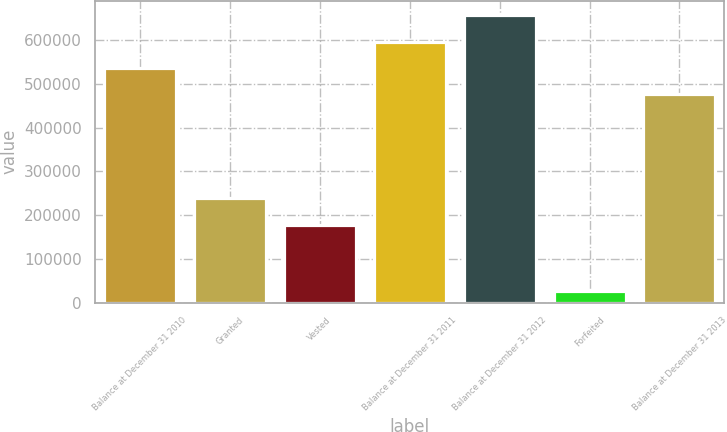Convert chart. <chart><loc_0><loc_0><loc_500><loc_500><bar_chart><fcel>Balance at December 31 2010<fcel>Granted<fcel>Vested<fcel>Balance at December 31 2011<fcel>Balance at December 31 2012<fcel>Forfeited<fcel>Balance at December 31 2013<nl><fcel>536228<fcel>238968<fcel>178653<fcel>596542<fcel>656857<fcel>26938<fcel>475913<nl></chart> 